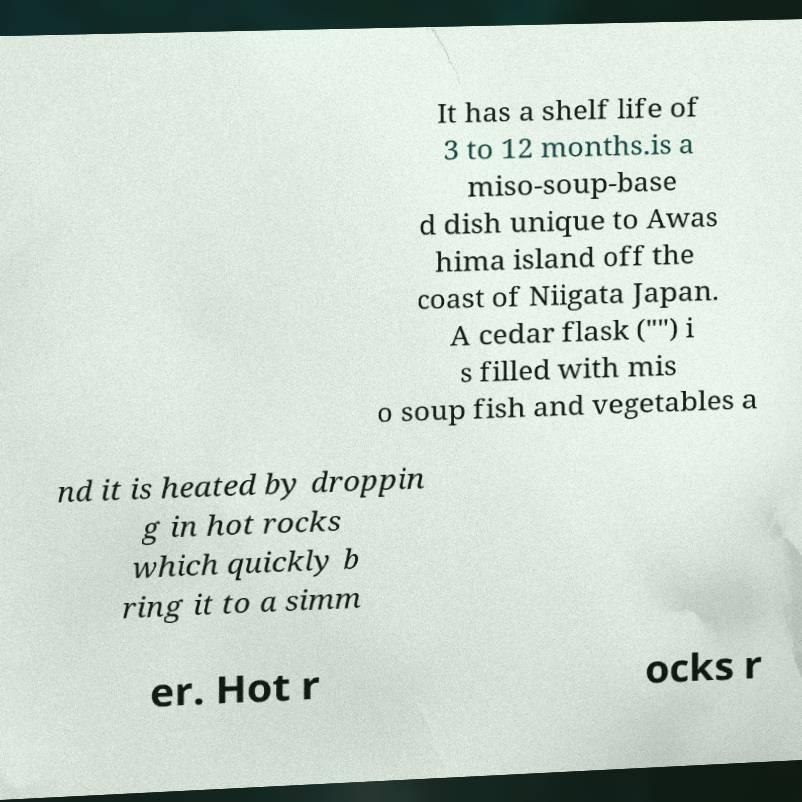Can you accurately transcribe the text from the provided image for me? It has a shelf life of 3 to 12 months.is a miso-soup-base d dish unique to Awas hima island off the coast of Niigata Japan. A cedar flask ("") i s filled with mis o soup fish and vegetables a nd it is heated by droppin g in hot rocks which quickly b ring it to a simm er. Hot r ocks r 